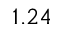Convert formula to latex. <formula><loc_0><loc_0><loc_500><loc_500>1 . 2 4</formula> 